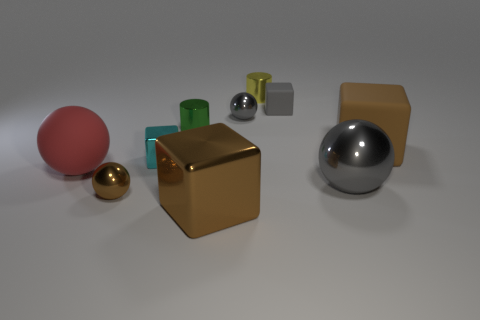Subtract all large brown shiny blocks. How many blocks are left? 3 Subtract all cyan cubes. How many cubes are left? 3 Subtract 1 cylinders. How many cylinders are left? 1 Subtract all green cylinders. How many brown blocks are left? 2 Subtract all yellow metallic cylinders. Subtract all green metal things. How many objects are left? 8 Add 5 rubber things. How many rubber things are left? 8 Add 5 matte objects. How many matte objects exist? 8 Subtract 1 green cylinders. How many objects are left? 9 Subtract all cylinders. How many objects are left? 8 Subtract all purple balls. Subtract all yellow blocks. How many balls are left? 4 